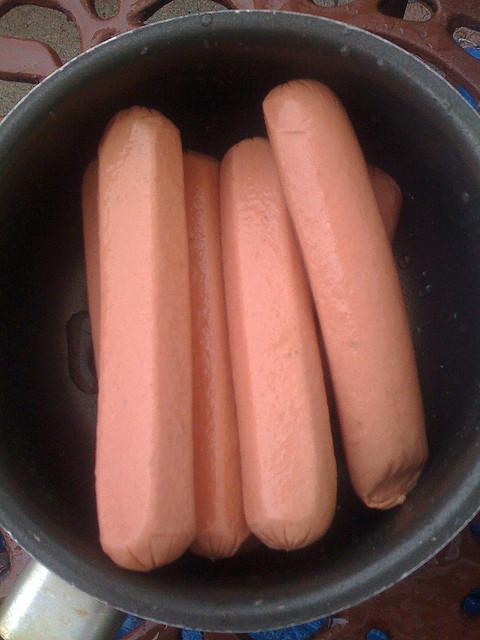What is bad about this food? Please explain your reasoning. high sodium. It is a partially cured meat which needs this substance to make it effective 